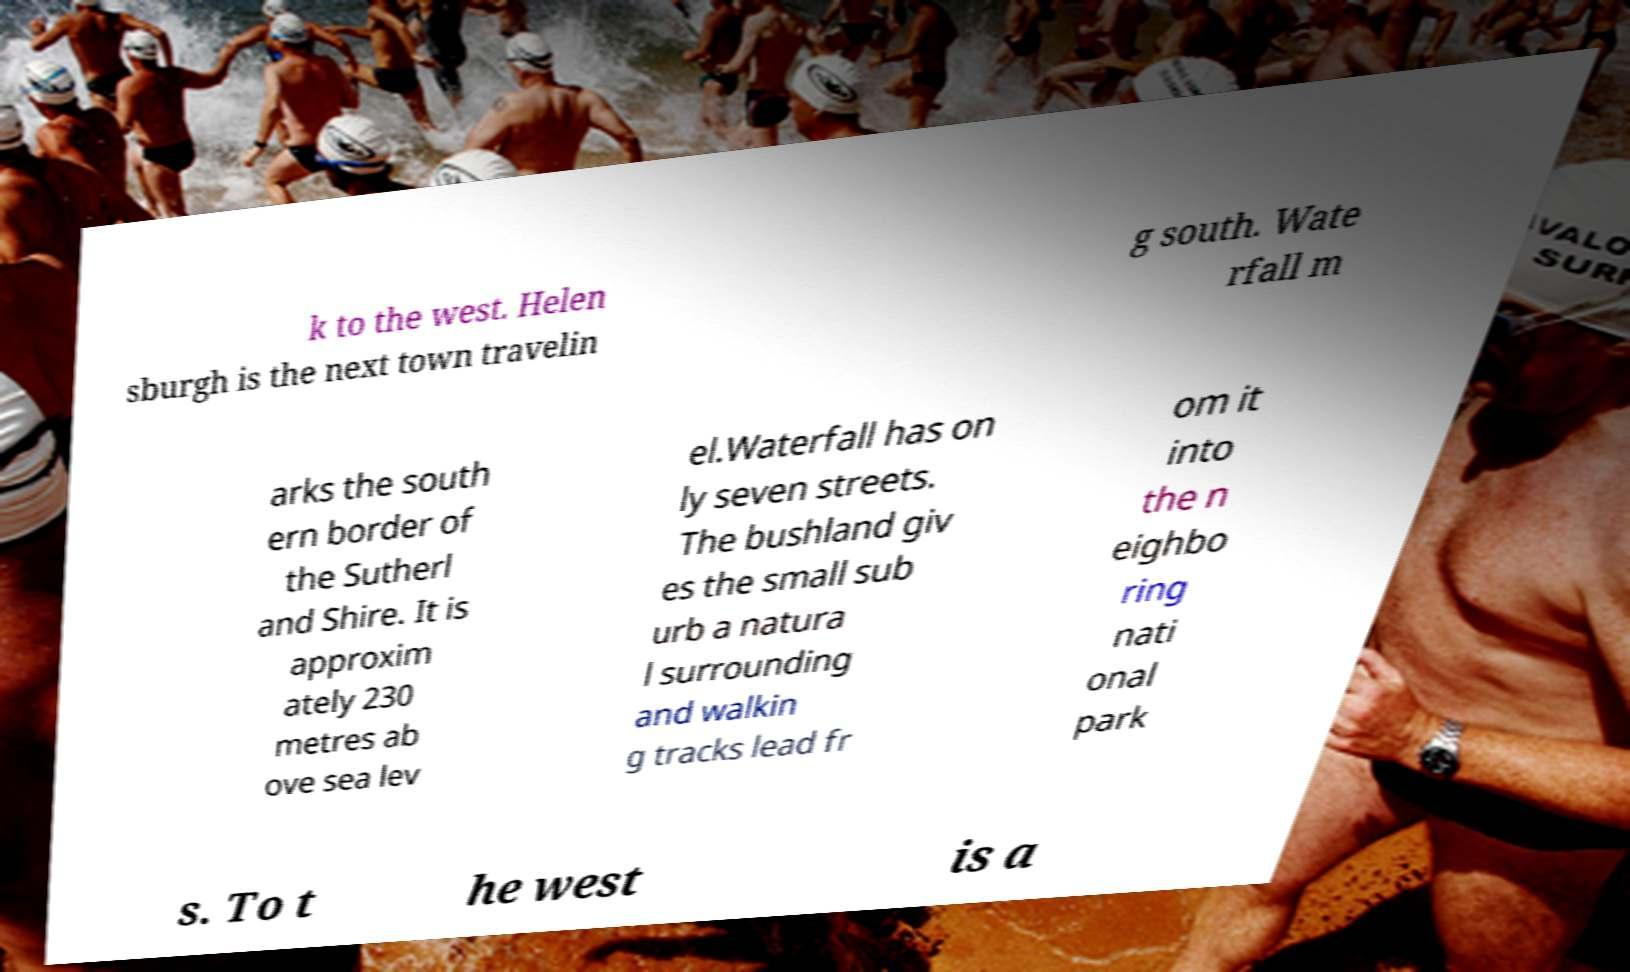Please read and relay the text visible in this image. What does it say? k to the west. Helen sburgh is the next town travelin g south. Wate rfall m arks the south ern border of the Sutherl and Shire. It is approxim ately 230 metres ab ove sea lev el.Waterfall has on ly seven streets. The bushland giv es the small sub urb a natura l surrounding and walkin g tracks lead fr om it into the n eighbo ring nati onal park s. To t he west is a 